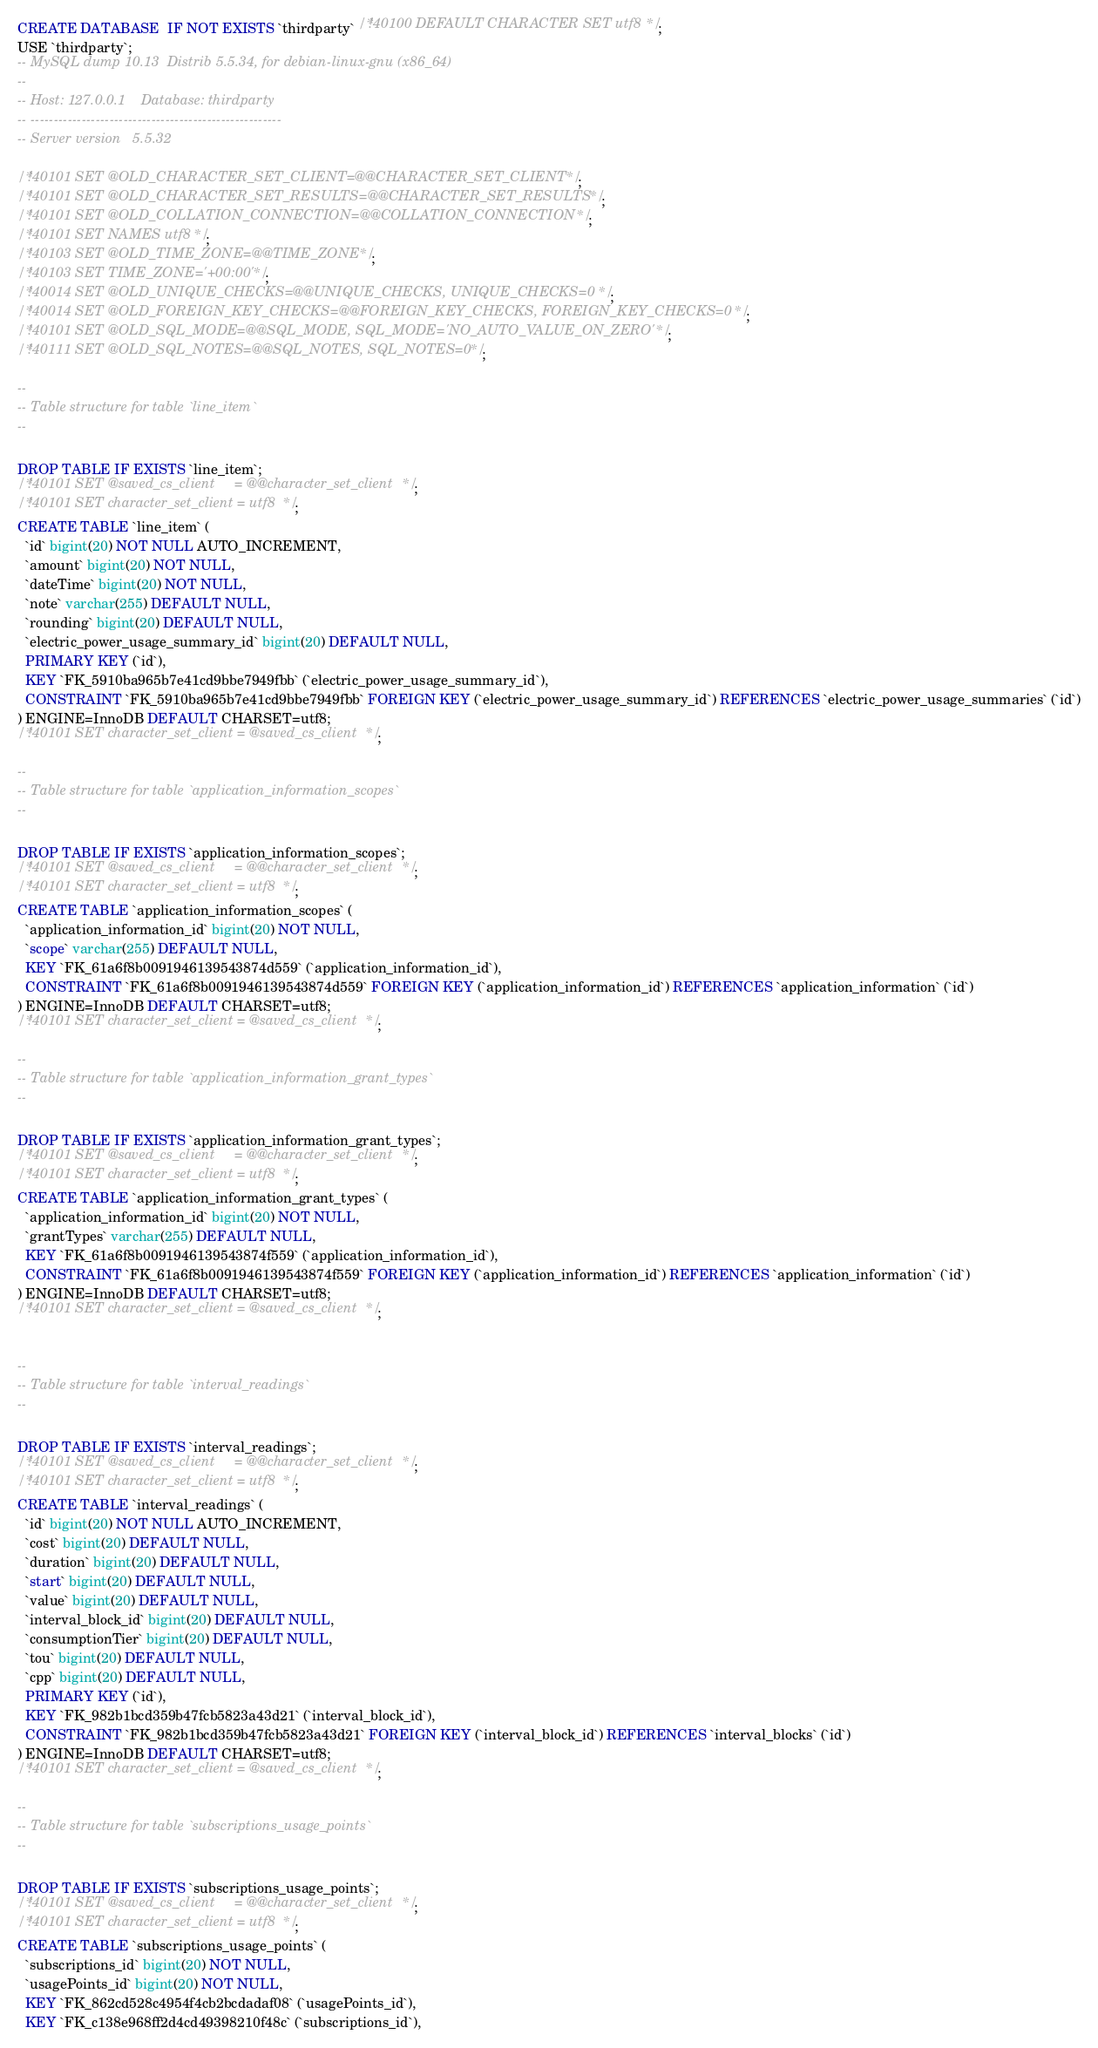<code> <loc_0><loc_0><loc_500><loc_500><_SQL_>CREATE DATABASE  IF NOT EXISTS `thirdparty` /*!40100 DEFAULT CHARACTER SET utf8 */;
USE `thirdparty`;
-- MySQL dump 10.13  Distrib 5.5.34, for debian-linux-gnu (x86_64)
--
-- Host: 127.0.0.1    Database: thirdparty
-- ------------------------------------------------------
-- Server version	5.5.32

/*!40101 SET @OLD_CHARACTER_SET_CLIENT=@@CHARACTER_SET_CLIENT */;
/*!40101 SET @OLD_CHARACTER_SET_RESULTS=@@CHARACTER_SET_RESULTS */;
/*!40101 SET @OLD_COLLATION_CONNECTION=@@COLLATION_CONNECTION */;
/*!40101 SET NAMES utf8 */;
/*!40103 SET @OLD_TIME_ZONE=@@TIME_ZONE */;
/*!40103 SET TIME_ZONE='+00:00' */;
/*!40014 SET @OLD_UNIQUE_CHECKS=@@UNIQUE_CHECKS, UNIQUE_CHECKS=0 */;
/*!40014 SET @OLD_FOREIGN_KEY_CHECKS=@@FOREIGN_KEY_CHECKS, FOREIGN_KEY_CHECKS=0 */;
/*!40101 SET @OLD_SQL_MODE=@@SQL_MODE, SQL_MODE='NO_AUTO_VALUE_ON_ZERO' */;
/*!40111 SET @OLD_SQL_NOTES=@@SQL_NOTES, SQL_NOTES=0 */;

--
-- Table structure for table `line_item`
--

DROP TABLE IF EXISTS `line_item`;
/*!40101 SET @saved_cs_client     = @@character_set_client */;
/*!40101 SET character_set_client = utf8 */;
CREATE TABLE `line_item` (
  `id` bigint(20) NOT NULL AUTO_INCREMENT,
  `amount` bigint(20) NOT NULL,
  `dateTime` bigint(20) NOT NULL,
  `note` varchar(255) DEFAULT NULL,
  `rounding` bigint(20) DEFAULT NULL,
  `electric_power_usage_summary_id` bigint(20) DEFAULT NULL,
  PRIMARY KEY (`id`),
  KEY `FK_5910ba965b7e41cd9bbe7949fbb` (`electric_power_usage_summary_id`),
  CONSTRAINT `FK_5910ba965b7e41cd9bbe7949fbb` FOREIGN KEY (`electric_power_usage_summary_id`) REFERENCES `electric_power_usage_summaries` (`id`)
) ENGINE=InnoDB DEFAULT CHARSET=utf8;
/*!40101 SET character_set_client = @saved_cs_client */;

--
-- Table structure for table `application_information_scopes`
--

DROP TABLE IF EXISTS `application_information_scopes`;
/*!40101 SET @saved_cs_client     = @@character_set_client */;
/*!40101 SET character_set_client = utf8 */;
CREATE TABLE `application_information_scopes` (
  `application_information_id` bigint(20) NOT NULL,
  `scope` varchar(255) DEFAULT NULL,
  KEY `FK_61a6f8b0091946139543874d559` (`application_information_id`),
  CONSTRAINT `FK_61a6f8b0091946139543874d559` FOREIGN KEY (`application_information_id`) REFERENCES `application_information` (`id`)
) ENGINE=InnoDB DEFAULT CHARSET=utf8;
/*!40101 SET character_set_client = @saved_cs_client */;

--
-- Table structure for table `application_information_grant_types`
--

DROP TABLE IF EXISTS `application_information_grant_types`;
/*!40101 SET @saved_cs_client     = @@character_set_client */;
/*!40101 SET character_set_client = utf8 */;
CREATE TABLE `application_information_grant_types` (
  `application_information_id` bigint(20) NOT NULL,
  `grantTypes` varchar(255) DEFAULT NULL,
  KEY `FK_61a6f8b0091946139543874f559` (`application_information_id`),
  CONSTRAINT `FK_61a6f8b0091946139543874f559` FOREIGN KEY (`application_information_id`) REFERENCES `application_information` (`id`)
) ENGINE=InnoDB DEFAULT CHARSET=utf8;
/*!40101 SET character_set_client = @saved_cs_client */;


--
-- Table structure for table `interval_readings`
--

DROP TABLE IF EXISTS `interval_readings`;
/*!40101 SET @saved_cs_client     = @@character_set_client */;
/*!40101 SET character_set_client = utf8 */;
CREATE TABLE `interval_readings` (
  `id` bigint(20) NOT NULL AUTO_INCREMENT,
  `cost` bigint(20) DEFAULT NULL,
  `duration` bigint(20) DEFAULT NULL,
  `start` bigint(20) DEFAULT NULL,
  `value` bigint(20) DEFAULT NULL,
  `interval_block_id` bigint(20) DEFAULT NULL,
  `consumptionTier` bigint(20) DEFAULT NULL,
  `tou` bigint(20) DEFAULT NULL,
  `cpp` bigint(20) DEFAULT NULL,
  PRIMARY KEY (`id`),
  KEY `FK_982b1bcd359b47fcb5823a43d21` (`interval_block_id`),
  CONSTRAINT `FK_982b1bcd359b47fcb5823a43d21` FOREIGN KEY (`interval_block_id`) REFERENCES `interval_blocks` (`id`)
) ENGINE=InnoDB DEFAULT CHARSET=utf8;
/*!40101 SET character_set_client = @saved_cs_client */;

--
-- Table structure for table `subscriptions_usage_points`
--

DROP TABLE IF EXISTS `subscriptions_usage_points`;
/*!40101 SET @saved_cs_client     = @@character_set_client */;
/*!40101 SET character_set_client = utf8 */;
CREATE TABLE `subscriptions_usage_points` (
  `subscriptions_id` bigint(20) NOT NULL,
  `usagePoints_id` bigint(20) NOT NULL,
  KEY `FK_862cd528c4954f4cb2bcdadaf08` (`usagePoints_id`),
  KEY `FK_c138e968ff2d4cd49398210f48c` (`subscriptions_id`),</code> 